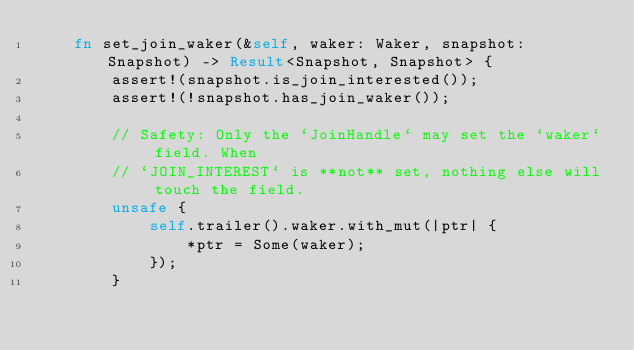<code> <loc_0><loc_0><loc_500><loc_500><_Rust_>    fn set_join_waker(&self, waker: Waker, snapshot: Snapshot) -> Result<Snapshot, Snapshot> {
        assert!(snapshot.is_join_interested());
        assert!(!snapshot.has_join_waker());

        // Safety: Only the `JoinHandle` may set the `waker` field. When
        // `JOIN_INTEREST` is **not** set, nothing else will touch the field.
        unsafe {
            self.trailer().waker.with_mut(|ptr| {
                *ptr = Some(waker);
            });
        }
</code> 